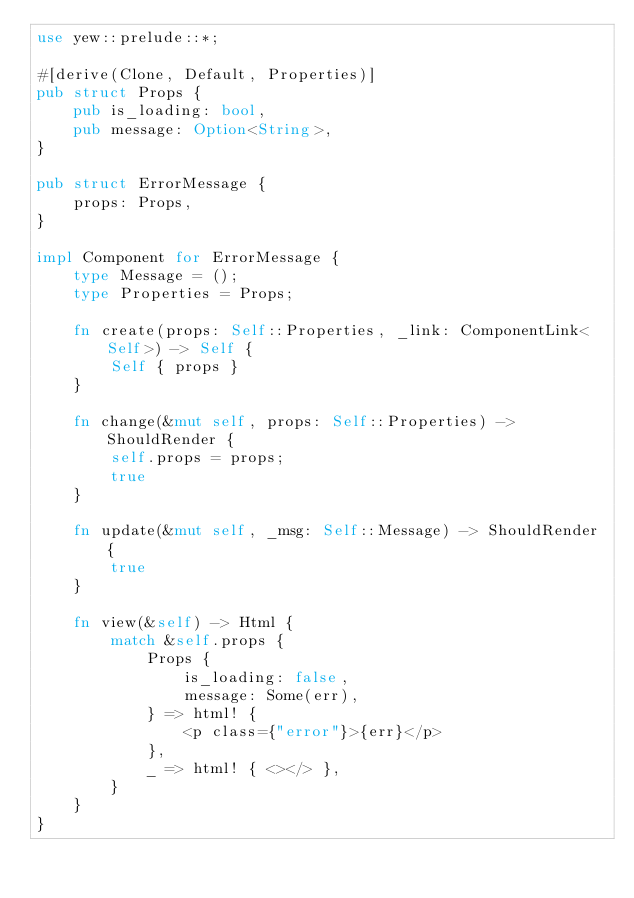Convert code to text. <code><loc_0><loc_0><loc_500><loc_500><_Rust_>use yew::prelude::*;

#[derive(Clone, Default, Properties)]
pub struct Props {
    pub is_loading: bool,
    pub message: Option<String>,
}

pub struct ErrorMessage {
    props: Props,
}

impl Component for ErrorMessage {
    type Message = ();
    type Properties = Props;

    fn create(props: Self::Properties, _link: ComponentLink<Self>) -> Self {
        Self { props }
    }

    fn change(&mut self, props: Self::Properties) -> ShouldRender {
        self.props = props;
        true
    }

    fn update(&mut self, _msg: Self::Message) -> ShouldRender {
        true
    }

    fn view(&self) -> Html {
        match &self.props {
            Props {
                is_loading: false,
                message: Some(err),
            } => html! {
                <p class={"error"}>{err}</p>
            },
            _ => html! { <></> },
        }
    }
}
</code> 